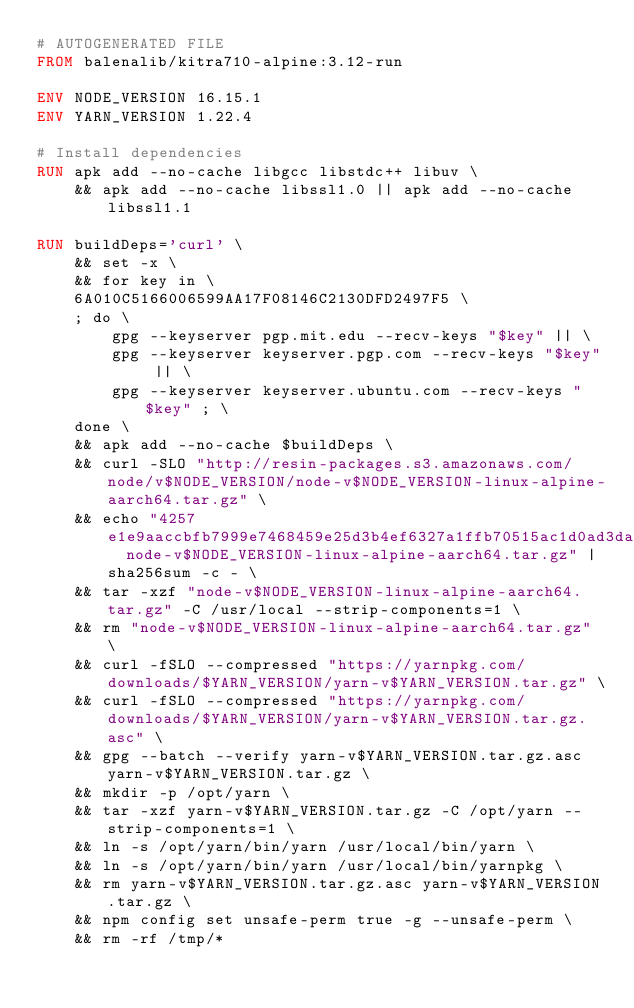Convert code to text. <code><loc_0><loc_0><loc_500><loc_500><_Dockerfile_># AUTOGENERATED FILE
FROM balenalib/kitra710-alpine:3.12-run

ENV NODE_VERSION 16.15.1
ENV YARN_VERSION 1.22.4

# Install dependencies
RUN apk add --no-cache libgcc libstdc++ libuv \
	&& apk add --no-cache libssl1.0 || apk add --no-cache libssl1.1

RUN buildDeps='curl' \
	&& set -x \
	&& for key in \
	6A010C5166006599AA17F08146C2130DFD2497F5 \
	; do \
		gpg --keyserver pgp.mit.edu --recv-keys "$key" || \
		gpg --keyserver keyserver.pgp.com --recv-keys "$key" || \
		gpg --keyserver keyserver.ubuntu.com --recv-keys "$key" ; \
	done \
	&& apk add --no-cache $buildDeps \
	&& curl -SLO "http://resin-packages.s3.amazonaws.com/node/v$NODE_VERSION/node-v$NODE_VERSION-linux-alpine-aarch64.tar.gz" \
	&& echo "4257e1e9aaccbfb7999e7468459e25d3b4ef6327a1ffb70515ac1d0ad3da8a26  node-v$NODE_VERSION-linux-alpine-aarch64.tar.gz" | sha256sum -c - \
	&& tar -xzf "node-v$NODE_VERSION-linux-alpine-aarch64.tar.gz" -C /usr/local --strip-components=1 \
	&& rm "node-v$NODE_VERSION-linux-alpine-aarch64.tar.gz" \
	&& curl -fSLO --compressed "https://yarnpkg.com/downloads/$YARN_VERSION/yarn-v$YARN_VERSION.tar.gz" \
	&& curl -fSLO --compressed "https://yarnpkg.com/downloads/$YARN_VERSION/yarn-v$YARN_VERSION.tar.gz.asc" \
	&& gpg --batch --verify yarn-v$YARN_VERSION.tar.gz.asc yarn-v$YARN_VERSION.tar.gz \
	&& mkdir -p /opt/yarn \
	&& tar -xzf yarn-v$YARN_VERSION.tar.gz -C /opt/yarn --strip-components=1 \
	&& ln -s /opt/yarn/bin/yarn /usr/local/bin/yarn \
	&& ln -s /opt/yarn/bin/yarn /usr/local/bin/yarnpkg \
	&& rm yarn-v$YARN_VERSION.tar.gz.asc yarn-v$YARN_VERSION.tar.gz \
	&& npm config set unsafe-perm true -g --unsafe-perm \
	&& rm -rf /tmp/*
</code> 